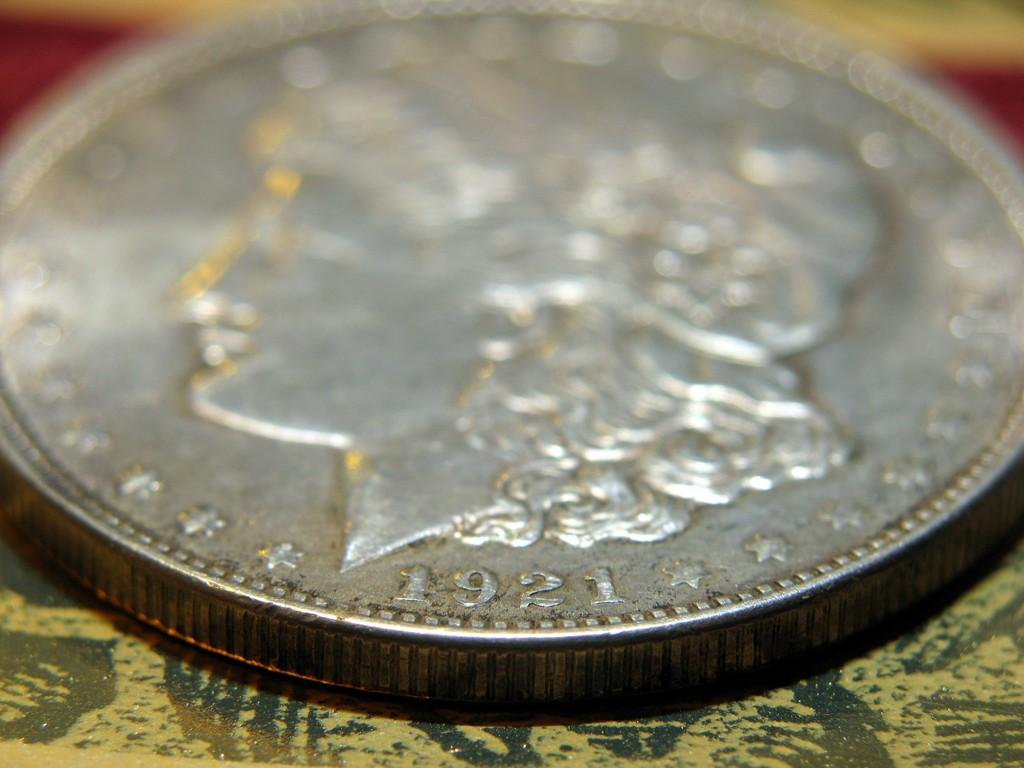<image>
Summarize the visual content of the image. a silver coin that says 1921 on the bottom edge of it 